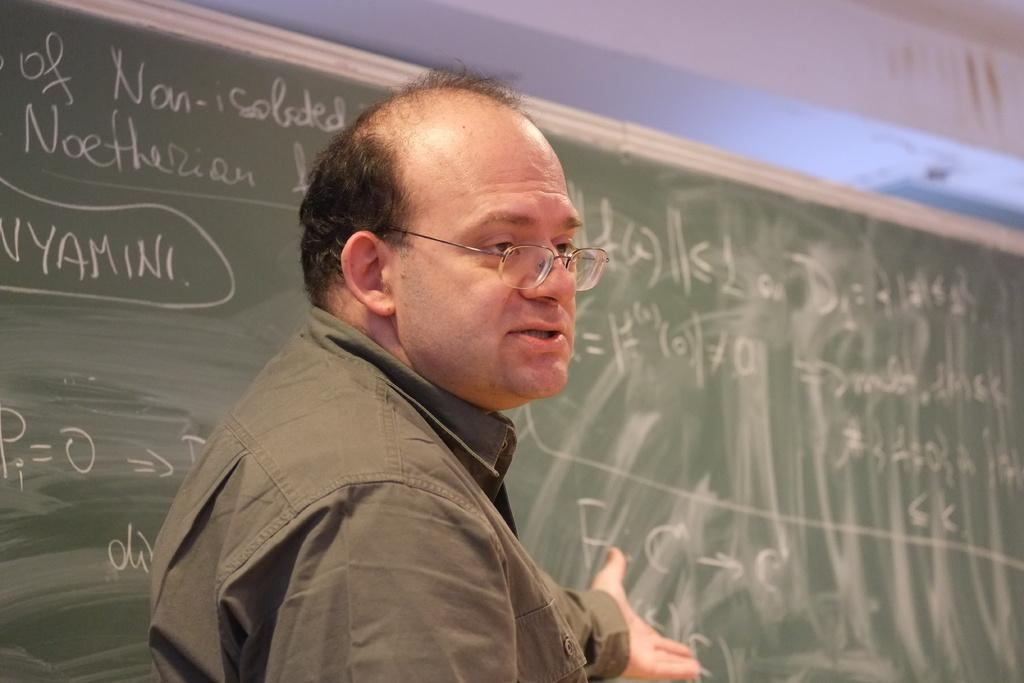Who is in the image? There is a man in the image. What is the man wearing? The man is wearing a green shirt. What accessory does the man have? The man has glasses. What is the man standing near? The man is standing near a green color school board. What might the man be doing in the image? The man appears to be explaining something. What type of toothpaste is the man using in the image? There is no toothpaste present in the image; the man is standing near a school board and appears to be explaining something. 